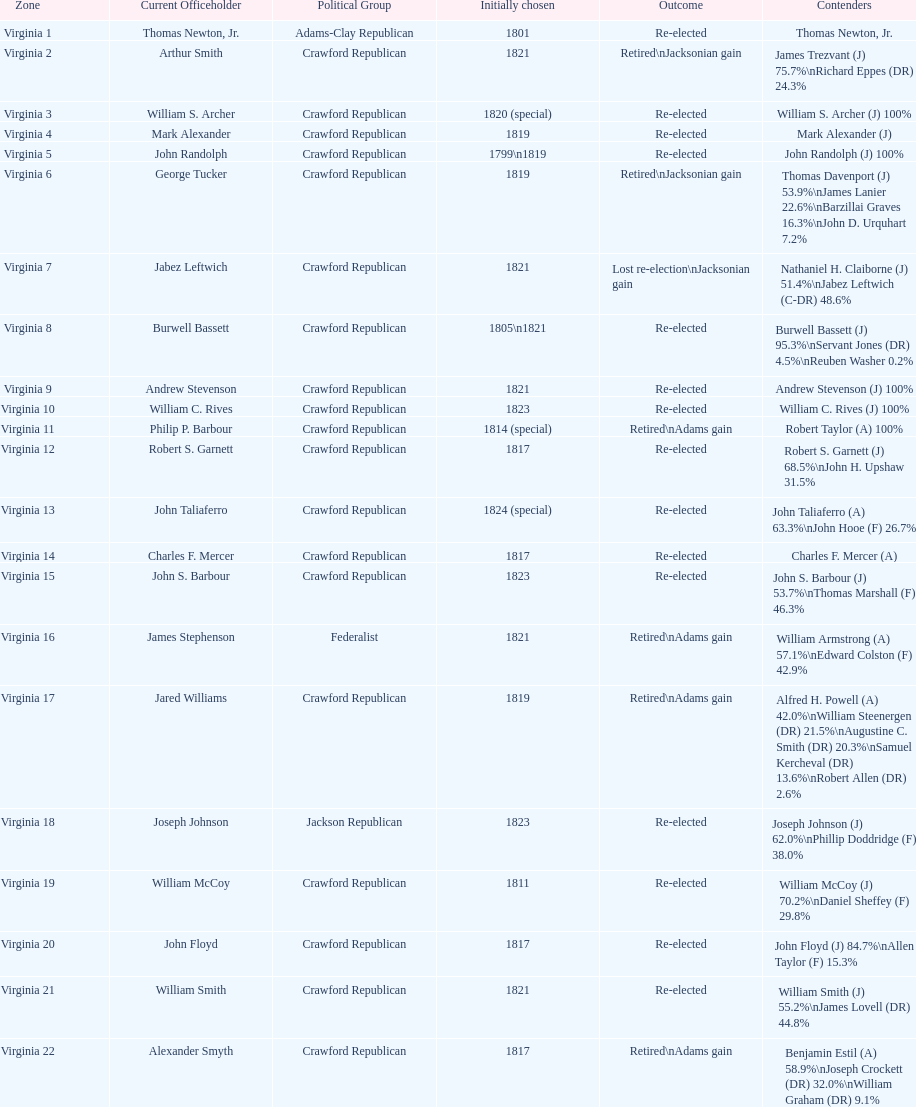How many districts are there in virginia? 22. 